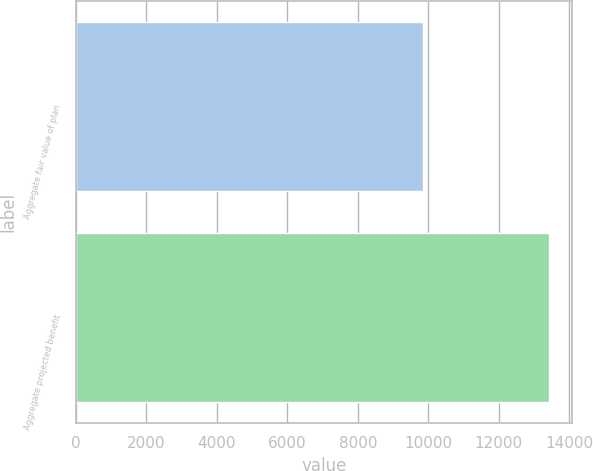<chart> <loc_0><loc_0><loc_500><loc_500><bar_chart><fcel>Aggregate fair value of plan<fcel>Aggregate projected benefit<nl><fcel>9851<fcel>13418<nl></chart> 